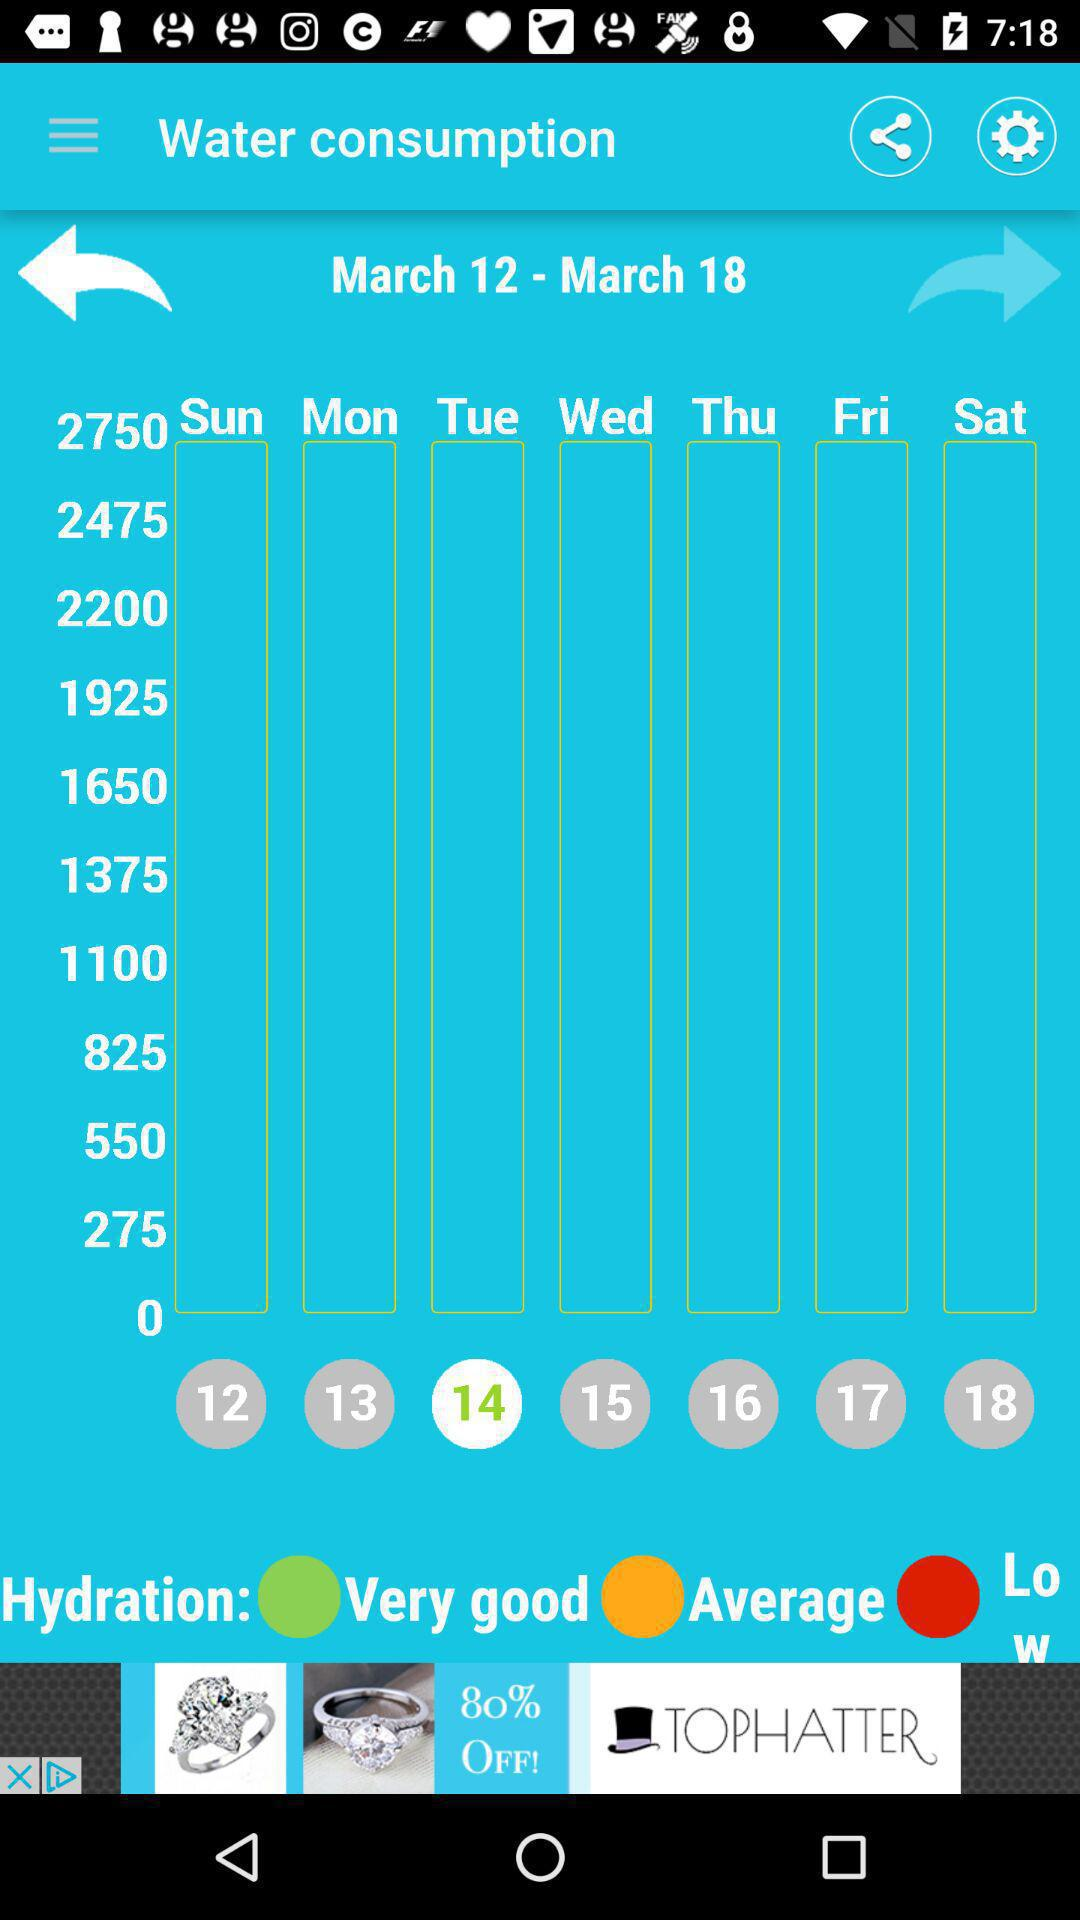What is the date duration given? The date duration is from March 12 to March 18. 